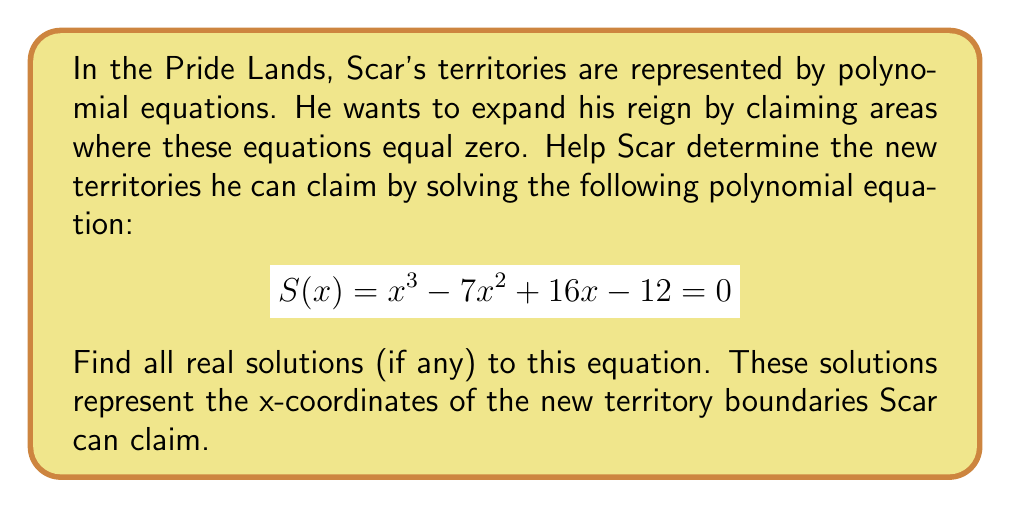Teach me how to tackle this problem. To solve this cubic equation, we'll use the rational root theorem and synthetic division.

1) First, let's find the possible rational roots. The factors of the constant term (12) are: ±1, ±2, ±3, ±4, ±6, ±12

2) Now, let's use synthetic division to test these potential roots:

Testing x = 1:
$$
\begin{array}{r}
1 \phantom{00} -7 \phantom{0} 16 \phantom{0} -12 \\
\underline{1 \phantom{00} -6 \phantom{0} 10} \\
1 \phantom{00} -6 \phantom{0} 10 \phantom{0} -2
\end{array}
$$

We found a root! S(1) = -2 + 10 - 6 + 1 = 3 ≠ 0, so x = 1 is not a solution.

Testing x = 3:
$$
\begin{array}{r}
1 \phantom{00} -7 \phantom{0} 16 \phantom{0} -12 \\
\underline{3 \phantom{00} -12 \phantom{0} 12} \\
1 \phantom{00} -4 \phantom{0} 4 \phantom{0} 0
\end{array}
$$

We found a root! S(3) = 0, so x = 3 is a solution.

3) Now we can factor out (x - 3):
$$S(x) = (x - 3)(x^2 - 4x + 4)$$

4) The quadratic factor can be solved using the quadratic formula or by recognizing it as a perfect square:
$$(x^2 - 4x + 4) = (x - 2)^2$$

5) Therefore, the full factorization is:
$$S(x) = (x - 3)(x - 2)^2$$

The solutions are x = 3 and x = 2 (with multiplicity 2).
Answer: The solutions are x = 2 (double root) and x = 3. Scar can claim new territories at x-coordinates 2 and 3 in the Pride Lands. 